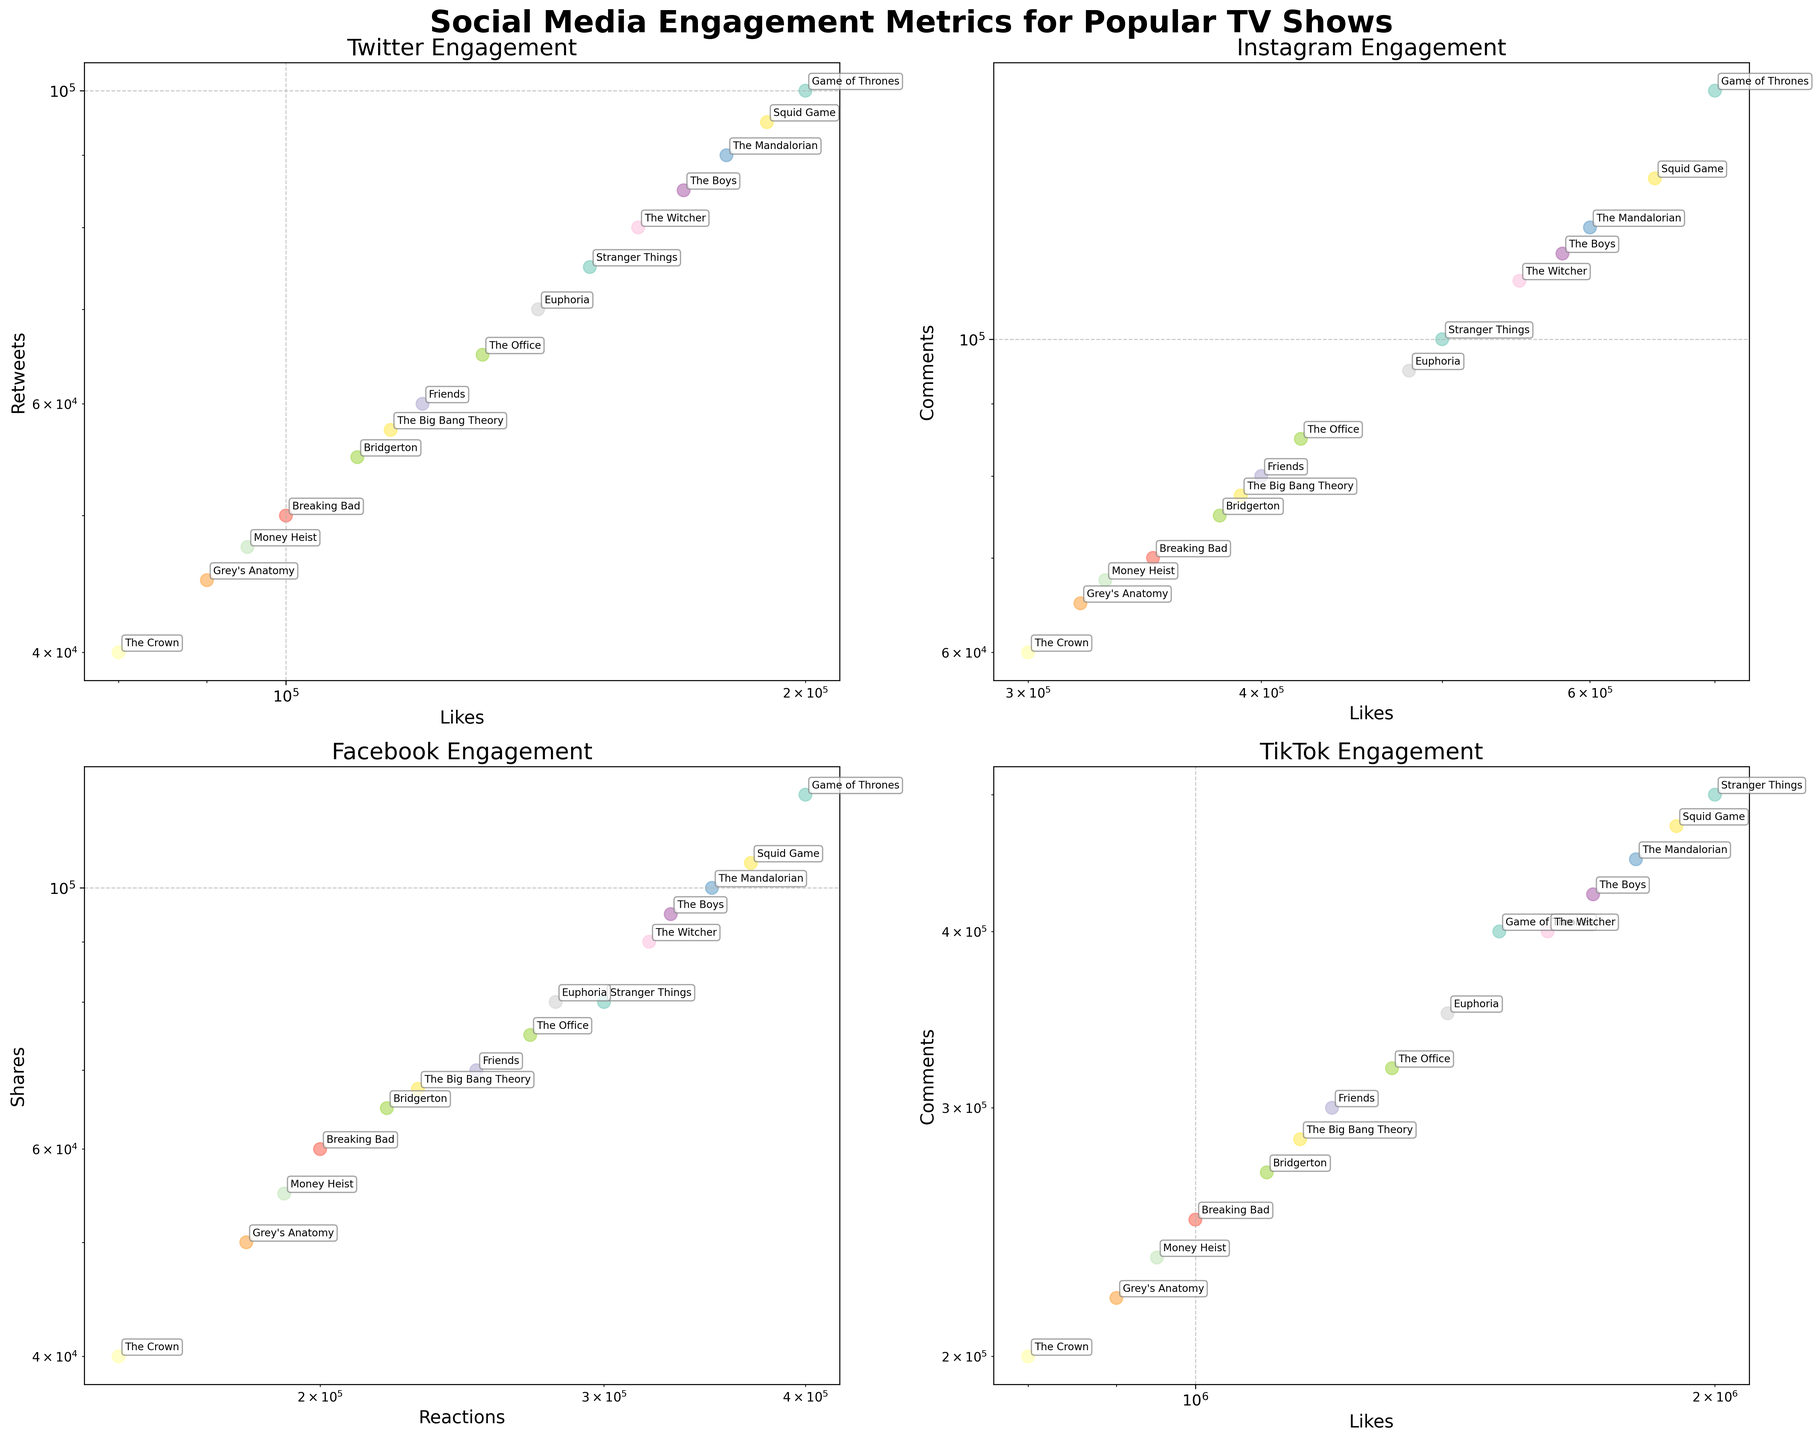Which TV show has the highest number of Twitter Retweets? Look at the scatter plot for Twitter and identify the highest point on the vertical axis representing Retweets.
Answer: Game of Thrones On Instagram, which TV show receives more comments: "Stranger Things" or "Breaking Bad"? Compare the y-positions of the points representing "Stranger Things" and "Breaking Bad" in the Instagram scatter plot.
Answer: Stranger Things In terms of Facebook engagement, which show has the higher combination of reactions and shares: "Squid Game" or "The Crown"? Sum the Facebook Reactions and Shares for both shows and compare the results.
Answer: Squid Game Which TV show has the lowest number of TikTok Likes and how do you identify it? Find the point closest to the origin on the horizontal axis in the TikTok scatter plot, then check the label.
Answer: Grey's Anatomy Between "The Mandalorian" and "Euphoria", which show has a higher number of Instagram Likes? Check the x-positions of the points representing "The Mandalorian" and "Euphoria" in the Instagram scatter plot.
Answer: The Mandalorian How do the Twitter Likes of "The Office" compare to those of "The Big Bang Theory"? Check the x-positions of the points representing "The Office" and "The Big Bang Theory" in the Twitter scatter plot to see which is further to the right.
Answer: The Office Considering the TikTok platform, which show has the highest combination of Likes and Comments? Sum the TikTok Likes and Comments for all shows and identify the highest total.
Answer: Stranger Things Which platform has the highest amount of engagement for "The Witcher" and what metrics support this? Compare the maximum values of the metrics (Likes, Retweets, Comments, Shares) for "The Witcher" across the Twitter, Instagram, Facebook, and TikTok plots.
Answer: TikTok Looking at the data visualization, can we infer that fantasy shows typically get more engagement on Instagram than crime dramas? Compare the positions of Fantasy (Game of Thrones, The Witcher) and Crime Drama (Breaking Bad, Money Heist) shows on the Instagram scatter plot.
Answer: Yes For the show "Friends", how does the number of Facebook Shares compare to that of "The Boys"? Compare the y-positions of the points representing "Friends" and "The Boys" in the Facebook scatter plot.
Answer: Lower 